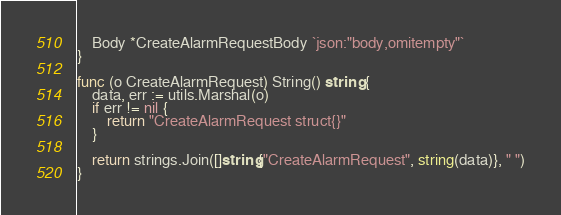<code> <loc_0><loc_0><loc_500><loc_500><_Go_>	Body *CreateAlarmRequestBody `json:"body,omitempty"`
}

func (o CreateAlarmRequest) String() string {
	data, err := utils.Marshal(o)
	if err != nil {
		return "CreateAlarmRequest struct{}"
	}

	return strings.Join([]string{"CreateAlarmRequest", string(data)}, " ")
}
</code> 